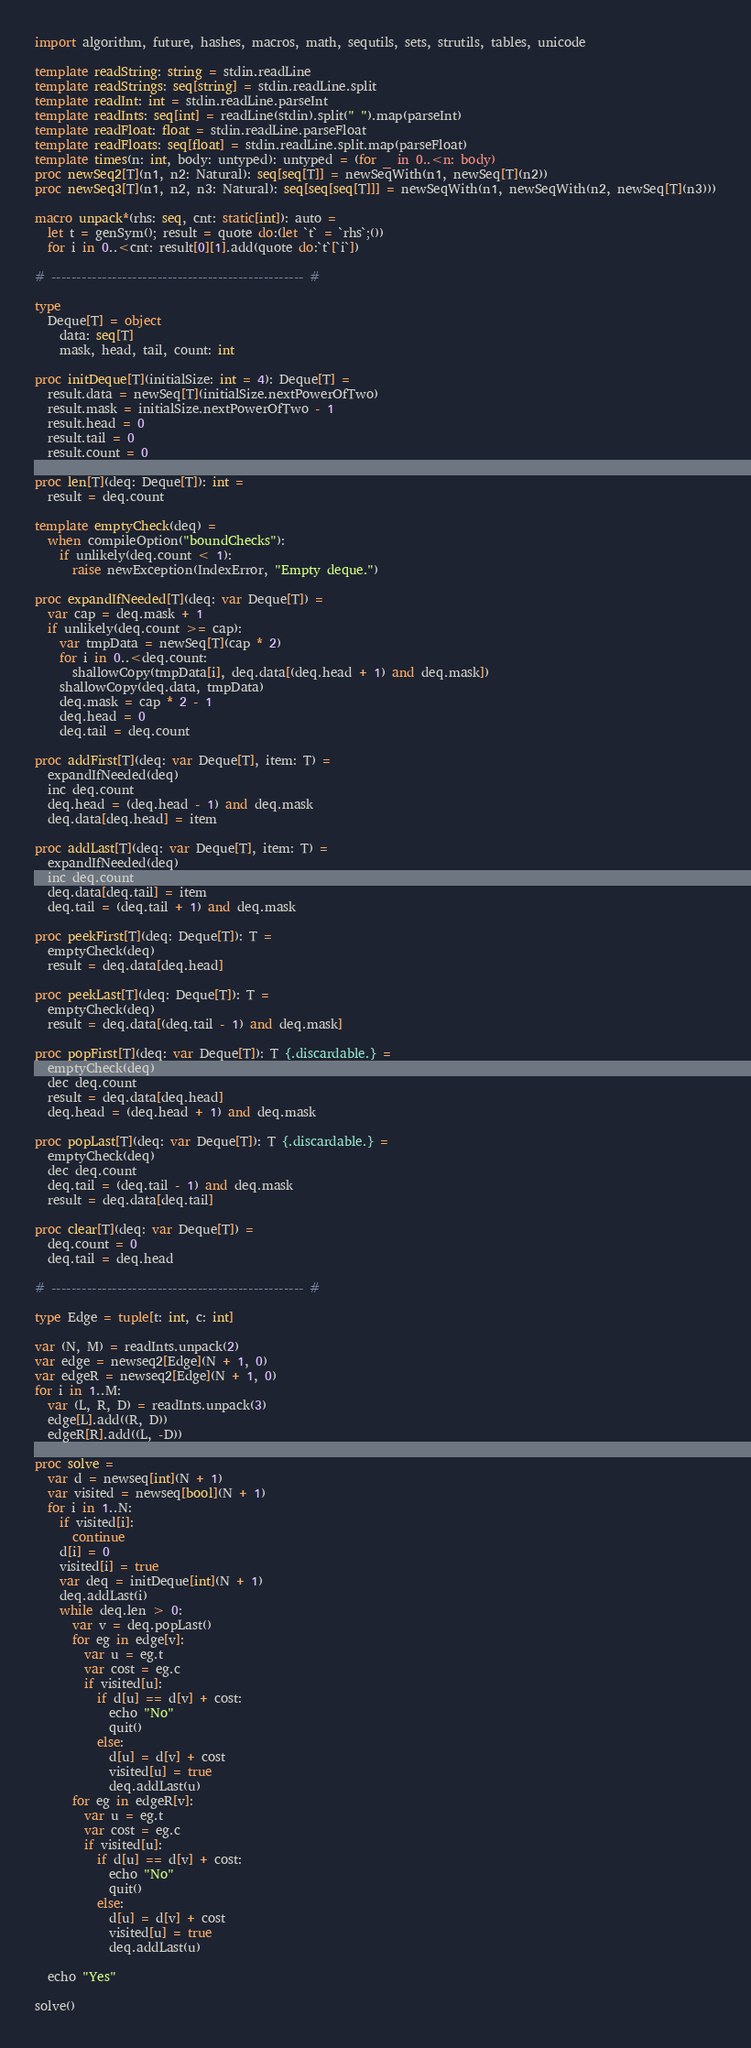Convert code to text. <code><loc_0><loc_0><loc_500><loc_500><_Nim_>import algorithm, future, hashes, macros, math, sequtils, sets, strutils, tables, unicode

template readString: string = stdin.readLine
template readStrings: seq[string] = stdin.readLine.split
template readInt: int = stdin.readLine.parseInt
template readInts: seq[int] = readLine(stdin).split(" ").map(parseInt)
template readFloat: float = stdin.readLine.parseFloat
template readFloats: seq[float] = stdin.readLine.split.map(parseFloat)
template times(n: int, body: untyped): untyped = (for _ in 0..<n: body)
proc newSeq2[T](n1, n2: Natural): seq[seq[T]] = newSeqWith(n1, newSeq[T](n2))
proc newSeq3[T](n1, n2, n3: Natural): seq[seq[seq[T]]] = newSeqWith(n1, newSeqWith(n2, newSeq[T](n3)))

macro unpack*(rhs: seq, cnt: static[int]): auto =
  let t = genSym(); result = quote do:(let `t` = `rhs`;())
  for i in 0..<cnt: result[0][1].add(quote do:`t`[`i`])

# -------------------------------------------------- #

type
  Deque[T] = object
    data: seq[T]
    mask, head, tail, count: int

proc initDeque[T](initialSize: int = 4): Deque[T] =
  result.data = newSeq[T](initialSize.nextPowerOfTwo)
  result.mask = initialSize.nextPowerOfTwo - 1
  result.head = 0
  result.tail = 0
  result.count = 0
  
proc len[T](deq: Deque[T]): int =
  result = deq.count

template emptyCheck(deq) =
  when compileOption("boundChecks"):
    if unlikely(deq.count < 1):
      raise newException(IndexError, "Empty deque.")

proc expandIfNeeded[T](deq: var Deque[T]) =
  var cap = deq.mask + 1
  if unlikely(deq.count >= cap):
    var tmpData = newSeq[T](cap * 2)
    for i in 0..<deq.count:
      shallowCopy(tmpData[i], deq.data[(deq.head + 1) and deq.mask])
    shallowCopy(deq.data, tmpData)
    deq.mask = cap * 2 - 1
    deq.head = 0
    deq.tail = deq.count

proc addFirst[T](deq: var Deque[T], item: T) =
  expandIfNeeded(deq)
  inc deq.count
  deq.head = (deq.head - 1) and deq.mask
  deq.data[deq.head] = item

proc addLast[T](deq: var Deque[T], item: T) =
  expandIfNeeded(deq)
  inc deq.count
  deq.data[deq.tail] = item
  deq.tail = (deq.tail + 1) and deq.mask

proc peekFirst[T](deq: Deque[T]): T =
  emptyCheck(deq)
  result = deq.data[deq.head]

proc peekLast[T](deq: Deque[T]): T =
  emptyCheck(deq)
  result = deq.data[(deq.tail - 1) and deq.mask]

proc popFirst[T](deq: var Deque[T]): T {.discardable.} =
  emptyCheck(deq)
  dec deq.count
  result = deq.data[deq.head]
  deq.head = (deq.head + 1) and deq.mask

proc popLast[T](deq: var Deque[T]): T {.discardable.} =
  emptyCheck(deq)
  dec deq.count
  deq.tail = (deq.tail - 1) and deq.mask
  result = deq.data[deq.tail]

proc clear[T](deq: var Deque[T]) =
  deq.count = 0
  deq.tail = deq.head

# -------------------------------------------------- #

type Edge = tuple[t: int, c: int]

var (N, M) = readInts.unpack(2)
var edge = newseq2[Edge](N + 1, 0)
var edgeR = newseq2[Edge](N + 1, 0)
for i in 1..M:
  var (L, R, D) = readInts.unpack(3)
  edge[L].add((R, D))
  edgeR[R].add((L, -D))

proc solve =
  var d = newseq[int](N + 1)
  var visited = newseq[bool](N + 1)
  for i in 1..N:
    if visited[i]:
      continue
    d[i] = 0
    visited[i] = true
    var deq = initDeque[int](N + 1)
    deq.addLast(i)
    while deq.len > 0:
      var v = deq.popLast()
      for eg in edge[v]:
        var u = eg.t
        var cost = eg.c
        if visited[u]:
          if d[u] == d[v] + cost:
            echo "No"
            quit()
          else:
            d[u] = d[v] + cost
            visited[u] = true
            deq.addLast(u)
      for eg in edgeR[v]:
        var u = eg.t
        var cost = eg.c
        if visited[u]:
          if d[u] == d[v] + cost:
            echo "No"
            quit()
          else:
            d[u] = d[v] + cost
            visited[u] = true
            deq.addLast(u)
    
  echo "Yes"

solve()
</code> 